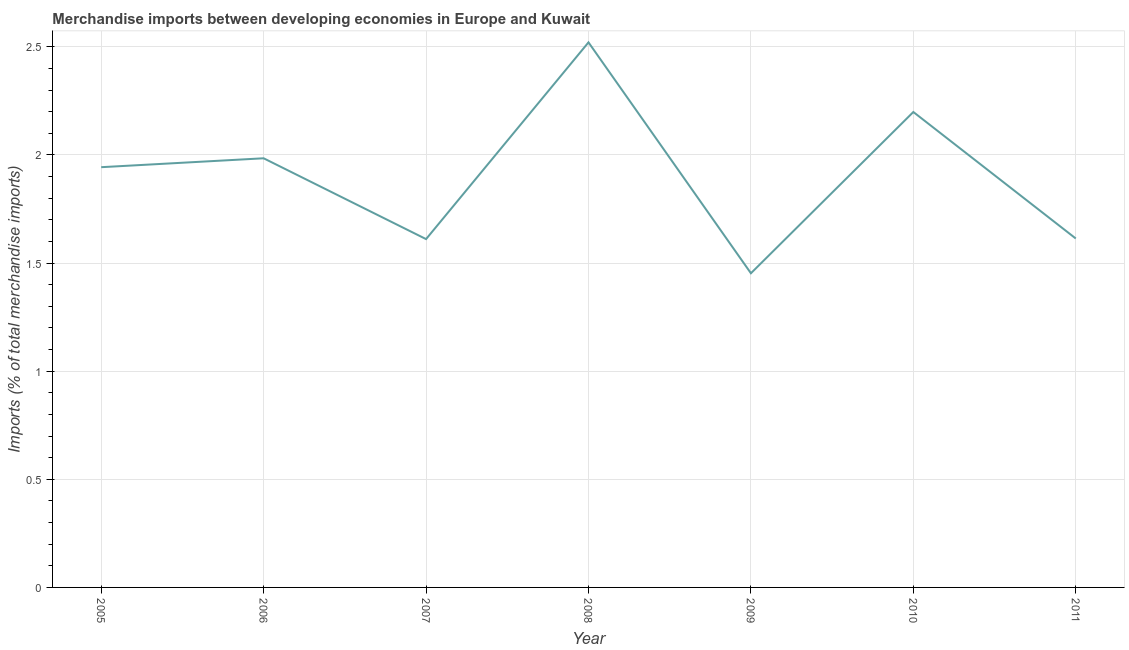What is the merchandise imports in 2008?
Your response must be concise. 2.52. Across all years, what is the maximum merchandise imports?
Keep it short and to the point. 2.52. Across all years, what is the minimum merchandise imports?
Your response must be concise. 1.45. What is the sum of the merchandise imports?
Your answer should be compact. 13.32. What is the difference between the merchandise imports in 2005 and 2007?
Ensure brevity in your answer.  0.33. What is the average merchandise imports per year?
Provide a short and direct response. 1.9. What is the median merchandise imports?
Provide a succinct answer. 1.94. In how many years, is the merchandise imports greater than 0.6 %?
Provide a succinct answer. 7. What is the ratio of the merchandise imports in 2006 to that in 2010?
Your answer should be very brief. 0.9. What is the difference between the highest and the second highest merchandise imports?
Provide a succinct answer. 0.32. Is the sum of the merchandise imports in 2009 and 2010 greater than the maximum merchandise imports across all years?
Offer a very short reply. Yes. What is the difference between the highest and the lowest merchandise imports?
Provide a short and direct response. 1.07. In how many years, is the merchandise imports greater than the average merchandise imports taken over all years?
Your answer should be compact. 4. Does the merchandise imports monotonically increase over the years?
Your response must be concise. No. How many years are there in the graph?
Your answer should be compact. 7. What is the difference between two consecutive major ticks on the Y-axis?
Your answer should be very brief. 0.5. Are the values on the major ticks of Y-axis written in scientific E-notation?
Provide a short and direct response. No. Does the graph contain any zero values?
Provide a short and direct response. No. Does the graph contain grids?
Offer a terse response. Yes. What is the title of the graph?
Your response must be concise. Merchandise imports between developing economies in Europe and Kuwait. What is the label or title of the X-axis?
Provide a succinct answer. Year. What is the label or title of the Y-axis?
Your answer should be very brief. Imports (% of total merchandise imports). What is the Imports (% of total merchandise imports) of 2005?
Offer a very short reply. 1.94. What is the Imports (% of total merchandise imports) of 2006?
Provide a short and direct response. 1.98. What is the Imports (% of total merchandise imports) in 2007?
Offer a very short reply. 1.61. What is the Imports (% of total merchandise imports) of 2008?
Your response must be concise. 2.52. What is the Imports (% of total merchandise imports) of 2009?
Give a very brief answer. 1.45. What is the Imports (% of total merchandise imports) in 2010?
Provide a succinct answer. 2.2. What is the Imports (% of total merchandise imports) of 2011?
Provide a succinct answer. 1.61. What is the difference between the Imports (% of total merchandise imports) in 2005 and 2006?
Your answer should be compact. -0.04. What is the difference between the Imports (% of total merchandise imports) in 2005 and 2007?
Offer a very short reply. 0.33. What is the difference between the Imports (% of total merchandise imports) in 2005 and 2008?
Offer a very short reply. -0.58. What is the difference between the Imports (% of total merchandise imports) in 2005 and 2009?
Provide a succinct answer. 0.49. What is the difference between the Imports (% of total merchandise imports) in 2005 and 2010?
Provide a short and direct response. -0.26. What is the difference between the Imports (% of total merchandise imports) in 2005 and 2011?
Keep it short and to the point. 0.33. What is the difference between the Imports (% of total merchandise imports) in 2006 and 2007?
Your answer should be very brief. 0.37. What is the difference between the Imports (% of total merchandise imports) in 2006 and 2008?
Your response must be concise. -0.54. What is the difference between the Imports (% of total merchandise imports) in 2006 and 2009?
Ensure brevity in your answer.  0.53. What is the difference between the Imports (% of total merchandise imports) in 2006 and 2010?
Provide a short and direct response. -0.21. What is the difference between the Imports (% of total merchandise imports) in 2006 and 2011?
Provide a succinct answer. 0.37. What is the difference between the Imports (% of total merchandise imports) in 2007 and 2008?
Ensure brevity in your answer.  -0.91. What is the difference between the Imports (% of total merchandise imports) in 2007 and 2009?
Your answer should be compact. 0.16. What is the difference between the Imports (% of total merchandise imports) in 2007 and 2010?
Keep it short and to the point. -0.59. What is the difference between the Imports (% of total merchandise imports) in 2007 and 2011?
Ensure brevity in your answer.  -0. What is the difference between the Imports (% of total merchandise imports) in 2008 and 2009?
Offer a terse response. 1.07. What is the difference between the Imports (% of total merchandise imports) in 2008 and 2010?
Give a very brief answer. 0.32. What is the difference between the Imports (% of total merchandise imports) in 2008 and 2011?
Give a very brief answer. 0.91. What is the difference between the Imports (% of total merchandise imports) in 2009 and 2010?
Provide a succinct answer. -0.75. What is the difference between the Imports (% of total merchandise imports) in 2009 and 2011?
Ensure brevity in your answer.  -0.16. What is the difference between the Imports (% of total merchandise imports) in 2010 and 2011?
Offer a very short reply. 0.59. What is the ratio of the Imports (% of total merchandise imports) in 2005 to that in 2006?
Ensure brevity in your answer.  0.98. What is the ratio of the Imports (% of total merchandise imports) in 2005 to that in 2007?
Offer a very short reply. 1.21. What is the ratio of the Imports (% of total merchandise imports) in 2005 to that in 2008?
Offer a very short reply. 0.77. What is the ratio of the Imports (% of total merchandise imports) in 2005 to that in 2009?
Keep it short and to the point. 1.34. What is the ratio of the Imports (% of total merchandise imports) in 2005 to that in 2010?
Ensure brevity in your answer.  0.88. What is the ratio of the Imports (% of total merchandise imports) in 2005 to that in 2011?
Offer a terse response. 1.2. What is the ratio of the Imports (% of total merchandise imports) in 2006 to that in 2007?
Provide a succinct answer. 1.23. What is the ratio of the Imports (% of total merchandise imports) in 2006 to that in 2008?
Make the answer very short. 0.79. What is the ratio of the Imports (% of total merchandise imports) in 2006 to that in 2009?
Make the answer very short. 1.37. What is the ratio of the Imports (% of total merchandise imports) in 2006 to that in 2010?
Make the answer very short. 0.9. What is the ratio of the Imports (% of total merchandise imports) in 2006 to that in 2011?
Provide a succinct answer. 1.23. What is the ratio of the Imports (% of total merchandise imports) in 2007 to that in 2008?
Provide a succinct answer. 0.64. What is the ratio of the Imports (% of total merchandise imports) in 2007 to that in 2009?
Give a very brief answer. 1.11. What is the ratio of the Imports (% of total merchandise imports) in 2007 to that in 2010?
Keep it short and to the point. 0.73. What is the ratio of the Imports (% of total merchandise imports) in 2007 to that in 2011?
Provide a succinct answer. 1. What is the ratio of the Imports (% of total merchandise imports) in 2008 to that in 2009?
Your answer should be very brief. 1.74. What is the ratio of the Imports (% of total merchandise imports) in 2008 to that in 2010?
Provide a succinct answer. 1.15. What is the ratio of the Imports (% of total merchandise imports) in 2008 to that in 2011?
Offer a terse response. 1.56. What is the ratio of the Imports (% of total merchandise imports) in 2009 to that in 2010?
Offer a very short reply. 0.66. What is the ratio of the Imports (% of total merchandise imports) in 2009 to that in 2011?
Provide a short and direct response. 0.9. What is the ratio of the Imports (% of total merchandise imports) in 2010 to that in 2011?
Provide a short and direct response. 1.36. 